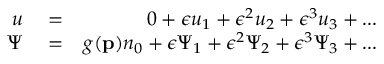Convert formula to latex. <formula><loc_0><loc_0><loc_500><loc_500>\begin{array} { r l r } { u } & = } & { 0 + \epsilon u _ { 1 } + \epsilon ^ { 2 } u _ { 2 } + \epsilon ^ { 3 } u _ { 3 } + \dots } \\ { \Psi } & = } & { g ( p ) n _ { 0 } + \epsilon \Psi _ { 1 } + \epsilon ^ { 2 } \Psi _ { 2 } + \epsilon ^ { 3 } \Psi _ { 3 } + \dots } \end{array}</formula> 